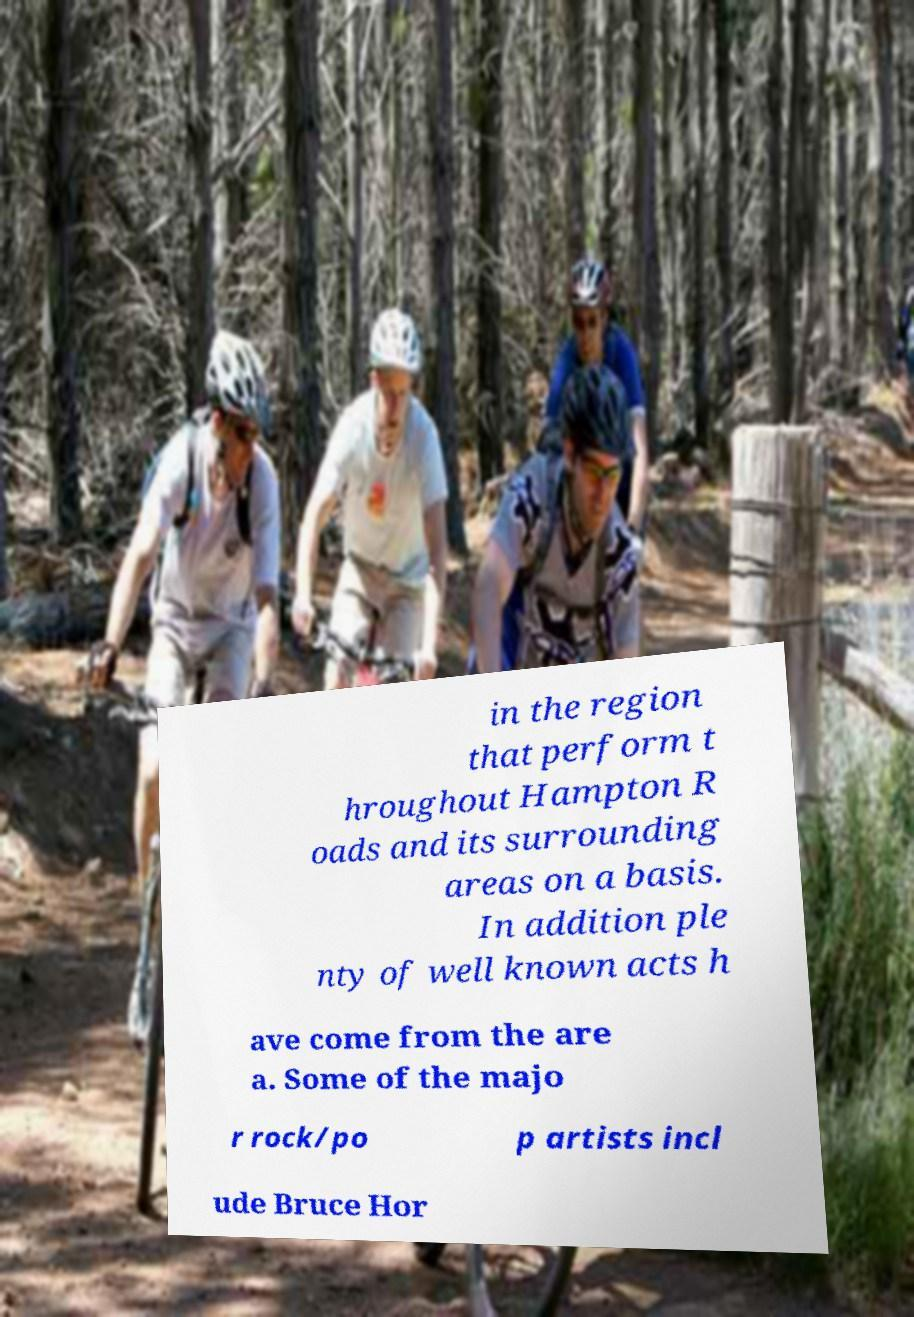What messages or text are displayed in this image? I need them in a readable, typed format. in the region that perform t hroughout Hampton R oads and its surrounding areas on a basis. In addition ple nty of well known acts h ave come from the are a. Some of the majo r rock/po p artists incl ude Bruce Hor 